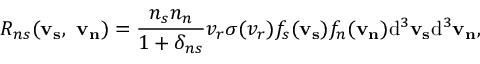Convert formula to latex. <formula><loc_0><loc_0><loc_500><loc_500>R _ { n s } ( v _ { s } , \ v _ { n } ) = \frac { n _ { s } n _ { n } } { 1 + \delta _ { n s } } v _ { r } \sigma ( v _ { r } ) f _ { s } ( v _ { s } ) f _ { n } ( v _ { n } ) d ^ { 3 } v _ { s } d ^ { 3 } v _ { n } ,</formula> 